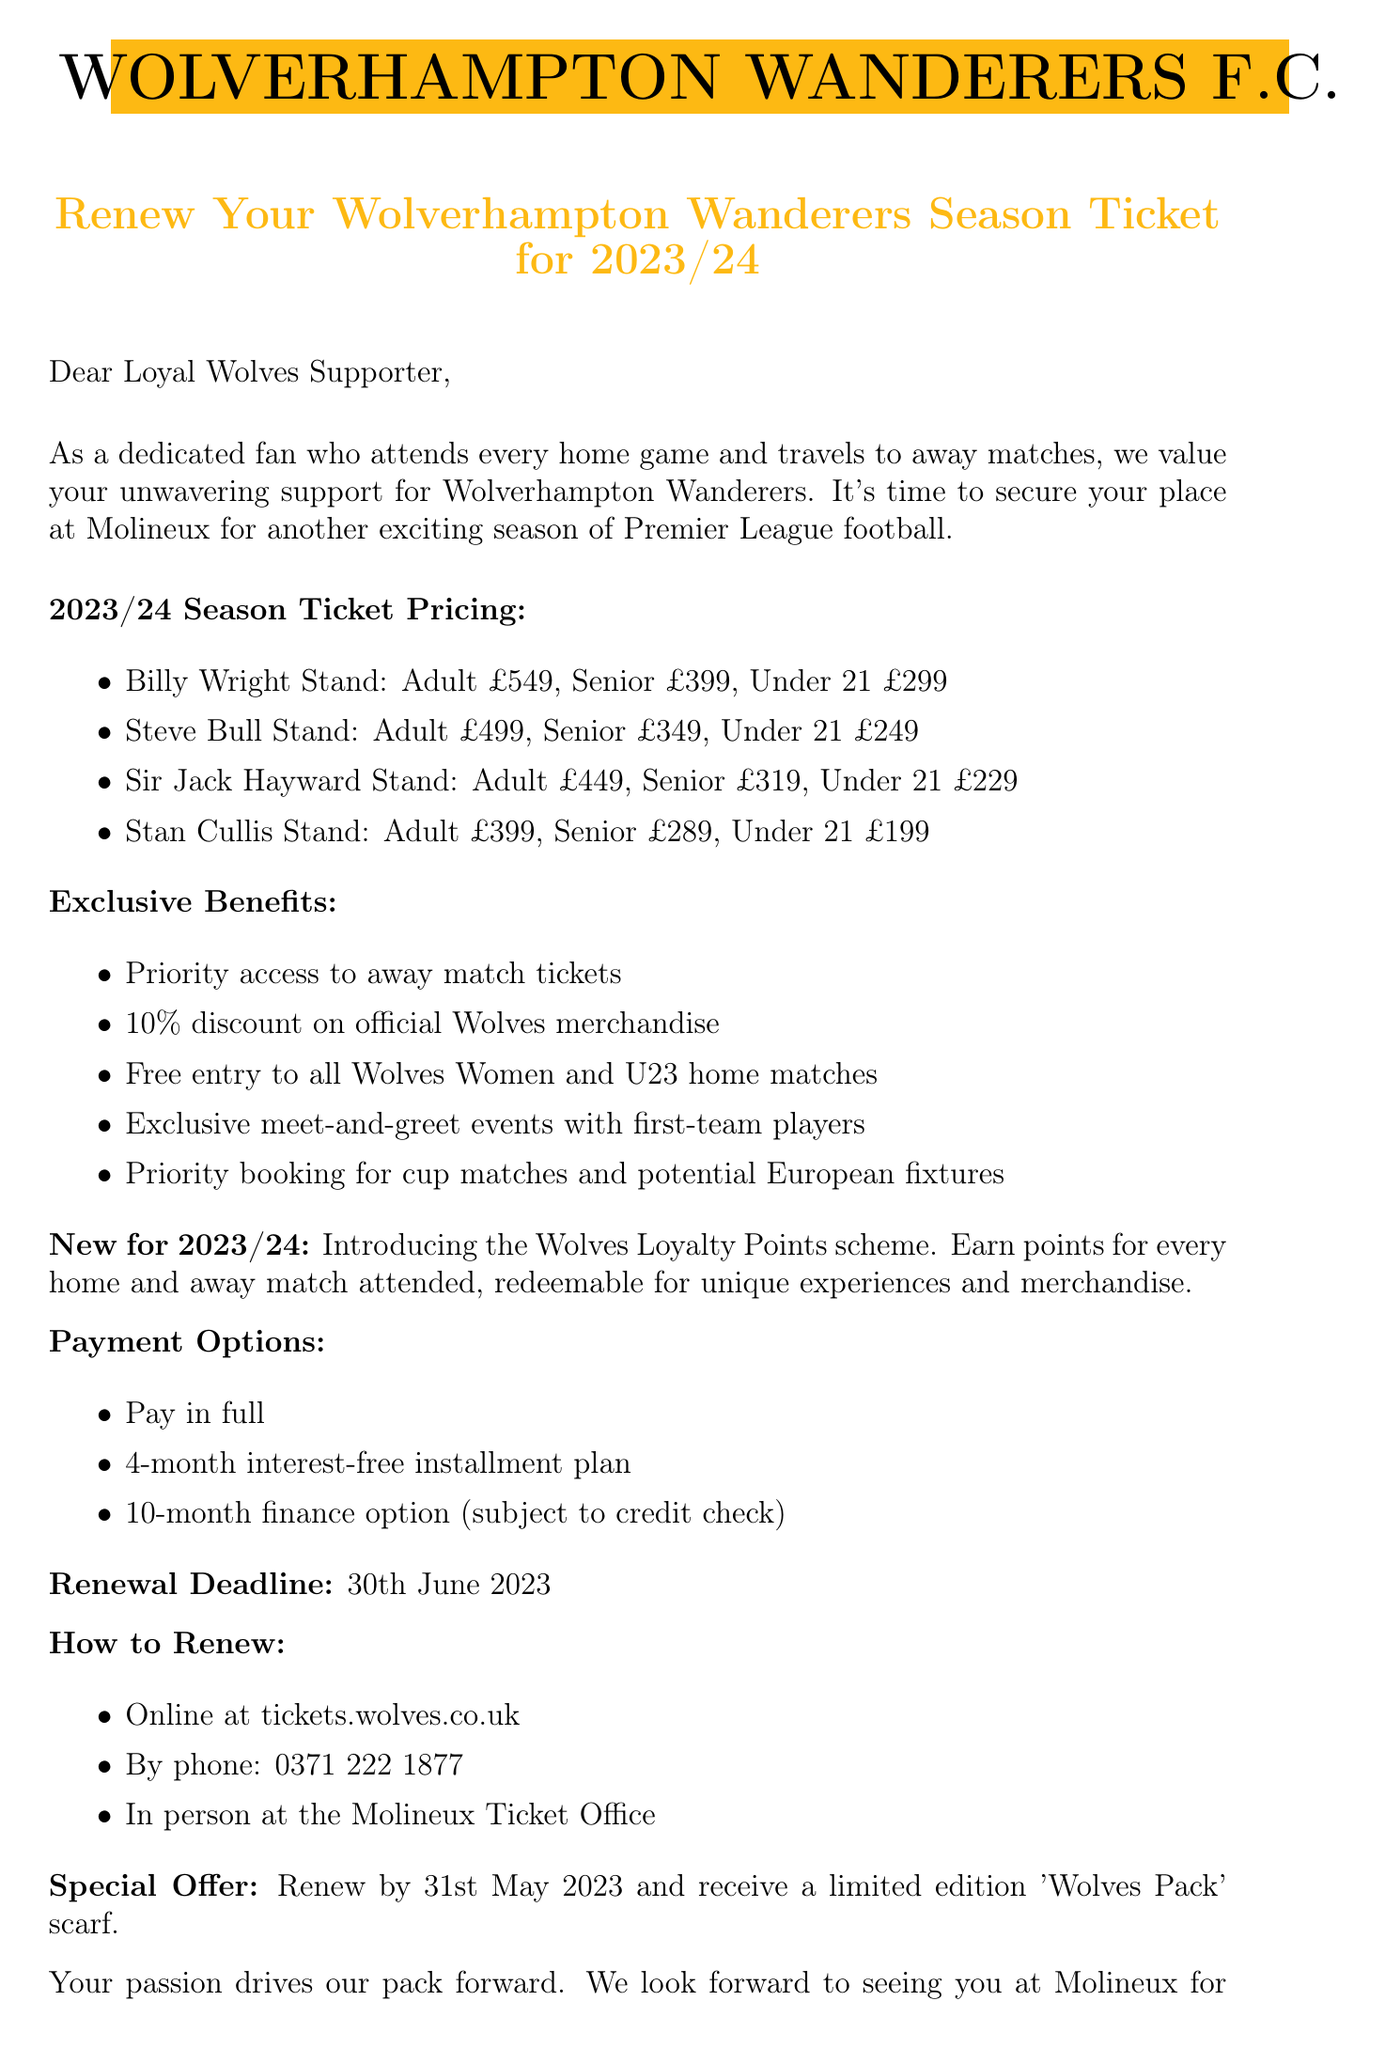What is the renewal deadline for the season ticket? The renewal deadline is explicitly mentioned in the document as 30th June 2023.
Answer: 30th June 2023 What is the price for an adult season ticket in the Billy Wright Stand? The document lists the pricing options, specifically noting the adult price for the Billy Wright Stand is £549.
Answer: £549 What exclusive benefit includes an entry to Wolves Women and U23 matches? The exclusive benefits include free entry to all Wolves Women and U23 home matches.
Answer: Free entry to all Wolves Women and U23 home matches What payment option is available for a 4-month interest-free plan? The payment options detail that there is a 4-month interest-free installment plan available for season ticket purchases.
Answer: 4-month interest-free installment plan What special offer is available for renewing by 31st May 2023? The document mentions that renewing by 31st May 2023 gives supporters a limited edition 'Wolves Pack' scarf.
Answer: Limited edition 'Wolves Pack' scarf What is the new feature introduced for the 2023/24 season? The new feature introduced is the Wolves Loyalty Points scheme that rewards fans for attendance.
Answer: Wolves Loyalty Points scheme What stands are included in the pricing options? The pricing options detail several stands: Billy Wright Stand, Steve Bull Stand, Sir Jack Hayward Stand, and Stan Cullis Stand.
Answer: Billy Wright Stand, Steve Bull Stand, Sir Jack Hayward Stand, Stan Cullis Stand Who is the signatory of the letter? The document indicates that Jeff Shi is the Executive Chairman and signatory of the letter.
Answer: Jeff Shi 